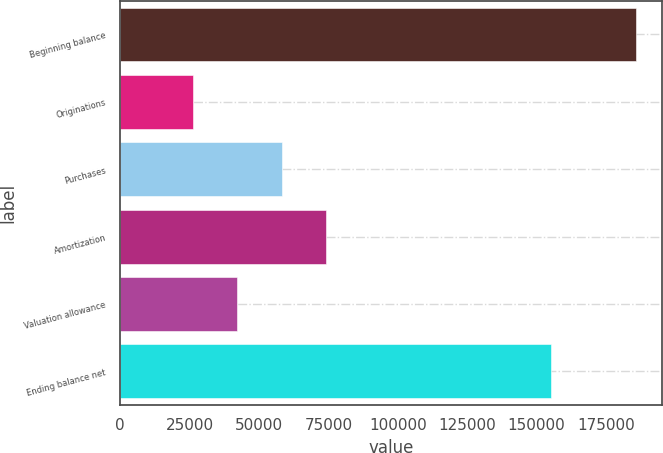<chart> <loc_0><loc_0><loc_500><loc_500><bar_chart><fcel>Beginning balance<fcel>Originations<fcel>Purchases<fcel>Amortization<fcel>Valuation allowance<fcel>Ending balance net<nl><fcel>185816<fcel>26285<fcel>58191.2<fcel>74144.3<fcel>42238.1<fcel>155347<nl></chart> 